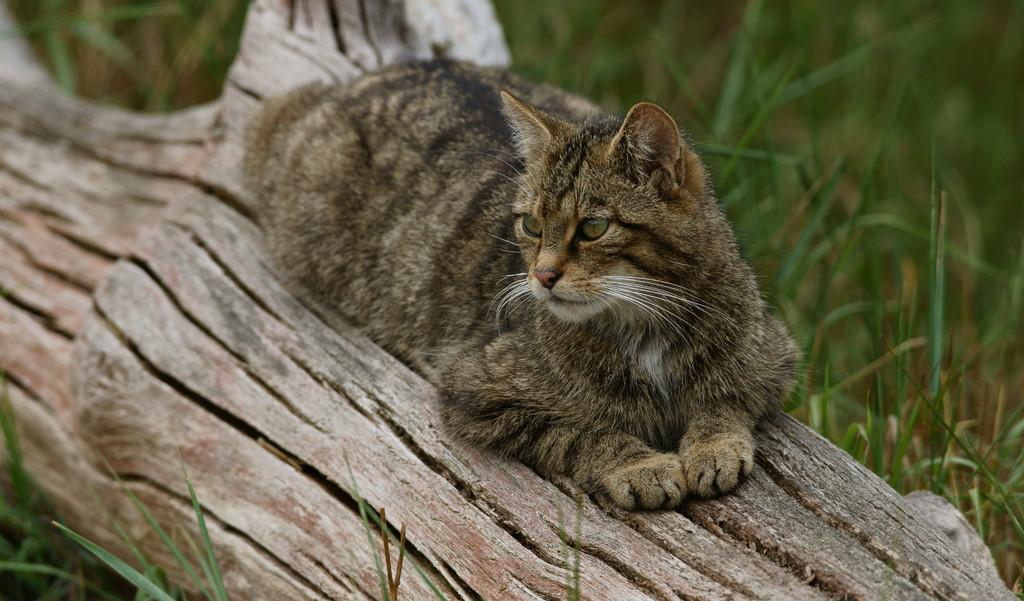What animal can be seen in the image? There is a cat in the image. Where is the cat located in the image? The cat is sitting on a branch of a tree. What is the tree placed on in the image? The tree is placed on the surface of the grass. How many pizzas are being delivered by the actor in the image? There is no actor or pizza present in the image; it features a cat sitting on a tree branch. 